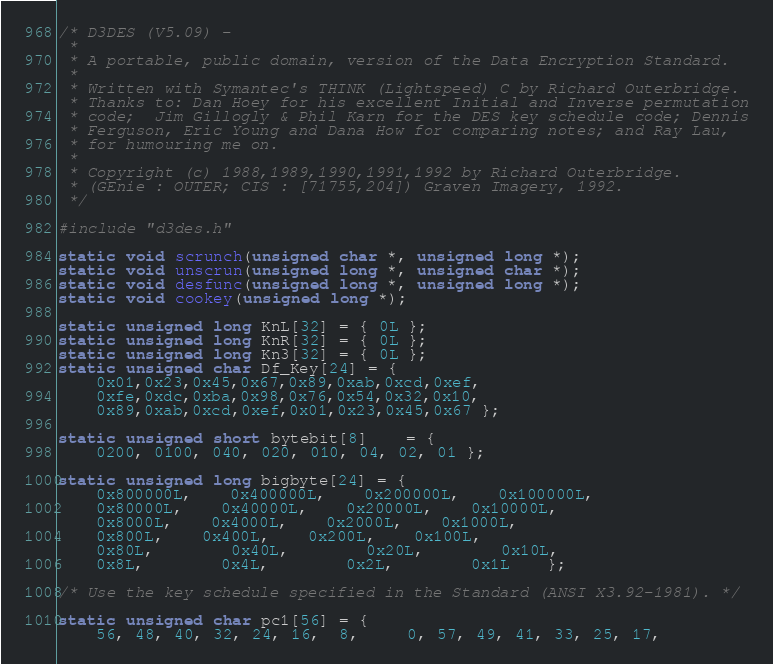<code> <loc_0><loc_0><loc_500><loc_500><_C_>/* D3DES (V5.09) -
 *
 * A portable, public domain, version of the Data Encryption Standard.
 *
 * Written with Symantec's THINK (Lightspeed) C by Richard Outerbridge.
 * Thanks to: Dan Hoey for his excellent Initial and Inverse permutation
 * code;  Jim Gillogly & Phil Karn for the DES key schedule code; Dennis
 * Ferguson, Eric Young and Dana How for comparing notes; and Ray Lau,
 * for humouring me on.
 *
 * Copyright (c) 1988,1989,1990,1991,1992 by Richard Outerbridge.
 * (GEnie : OUTER; CIS : [71755,204]) Graven Imagery, 1992.
 */

#include "d3des.h"

static void scrunch(unsigned char *, unsigned long *);
static void unscrun(unsigned long *, unsigned char *);
static void desfunc(unsigned long *, unsigned long *);
static void cookey(unsigned long *);

static unsigned long KnL[32] = { 0L };
static unsigned long KnR[32] = { 0L };
static unsigned long Kn3[32] = { 0L };
static unsigned char Df_Key[24] = {
	0x01,0x23,0x45,0x67,0x89,0xab,0xcd,0xef,
	0xfe,0xdc,0xba,0x98,0x76,0x54,0x32,0x10,
	0x89,0xab,0xcd,0xef,0x01,0x23,0x45,0x67 };

static unsigned short bytebit[8]	= {
	0200, 0100, 040, 020, 010, 04, 02, 01 };

static unsigned long bigbyte[24] = {
	0x800000L,	0x400000L,	0x200000L,	0x100000L,
	0x80000L,	0x40000L,	0x20000L,	0x10000L,
	0x8000L,	0x4000L,	0x2000L,	0x1000L,
	0x800L, 	0x400L, 	0x200L, 	0x100L,
	0x80L,		0x40L,		0x20L,		0x10L,
	0x8L,		0x4L,		0x2L,		0x1L	};

/* Use the key schedule specified in the Standard (ANSI X3.92-1981). */

static unsigned char pc1[56] = {
	56, 48, 40, 32, 24, 16,  8,	 0, 57, 49, 41, 33, 25, 17,</code> 